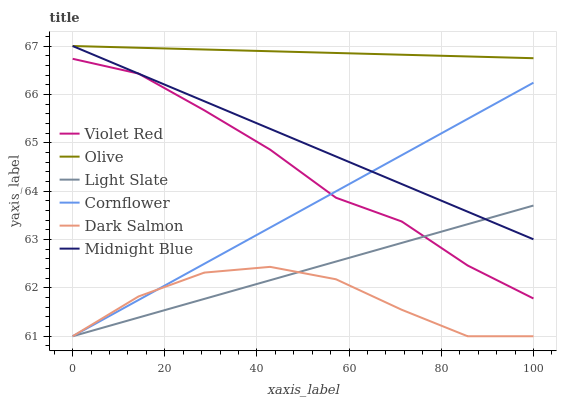Does Dark Salmon have the minimum area under the curve?
Answer yes or no. Yes. Does Olive have the maximum area under the curve?
Answer yes or no. Yes. Does Violet Red have the minimum area under the curve?
Answer yes or no. No. Does Violet Red have the maximum area under the curve?
Answer yes or no. No. Is Olive the smoothest?
Answer yes or no. Yes. Is Dark Salmon the roughest?
Answer yes or no. Yes. Is Violet Red the smoothest?
Answer yes or no. No. Is Violet Red the roughest?
Answer yes or no. No. Does Cornflower have the lowest value?
Answer yes or no. Yes. Does Violet Red have the lowest value?
Answer yes or no. No. Does Olive have the highest value?
Answer yes or no. Yes. Does Violet Red have the highest value?
Answer yes or no. No. Is Dark Salmon less than Olive?
Answer yes or no. Yes. Is Olive greater than Dark Salmon?
Answer yes or no. Yes. Does Cornflower intersect Midnight Blue?
Answer yes or no. Yes. Is Cornflower less than Midnight Blue?
Answer yes or no. No. Is Cornflower greater than Midnight Blue?
Answer yes or no. No. Does Dark Salmon intersect Olive?
Answer yes or no. No. 